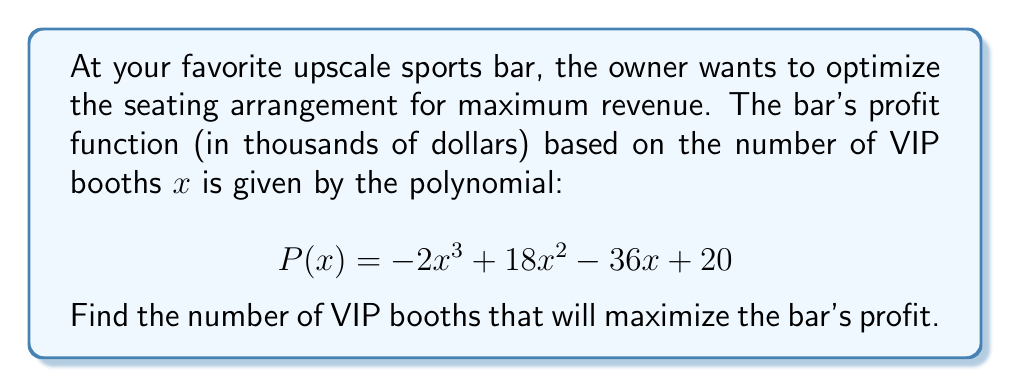Can you answer this question? To find the number of VIP booths that maximizes profit, we need to find the roots of the derivative of the profit function. This will give us the critical points, including the maximum.

Step 1: Find the derivative of $P(x)$
$$P'(x) = -6x^2 + 36x - 36$$

Step 2: Factor the derivative
$$P'(x) = -6(x^2 - 6x + 6)$$
$$P'(x) = -6(x - 3)^2 + 18$$

Step 3: Set the derivative equal to zero and solve
$$-6(x - 3)^2 + 18 = 0$$
$$(x - 3)^2 = 3$$
$$x - 3 = \pm\sqrt{3}$$
$$x = 3 \pm \sqrt{3}$$

Step 4: Simplify the solutions
$$x_1 = 3 + \sqrt{3} \approx 4.73$$
$$x_2 = 3 - \sqrt{3} \approx 1.27$$

Step 5: Determine which solution maximizes profit
Since we're looking for a maximum and the leading coefficient of the original polynomial is negative, the smaller value of $x$ will give us the maximum profit.

Step 6: Round to the nearest whole number
Since we can't have a fractional number of booths, we round 1.27 to 1.

Therefore, the number of VIP booths that will maximize the bar's profit is 1.
Answer: 1 VIP booth 